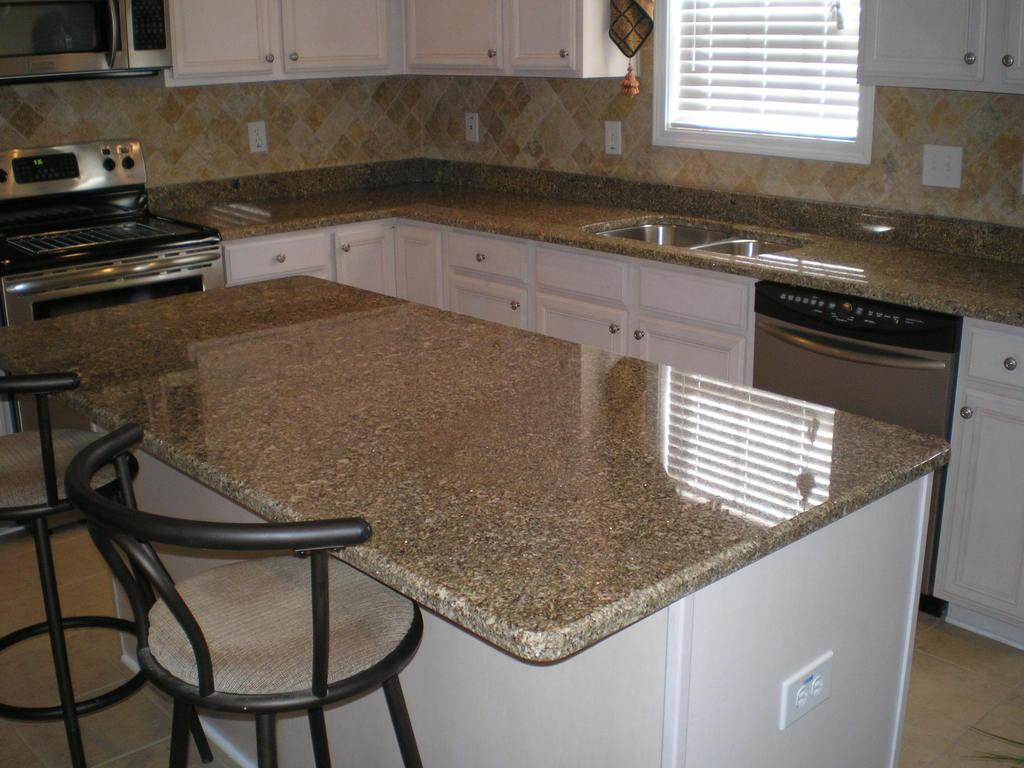Describe this image in one or two sentences. The image is clicked in the kitchen. In this image, there are two chairs, table made up of rock, platform along with sink, cupboards, and gas stove. At the top, there are cupboards, windows, and wall. 